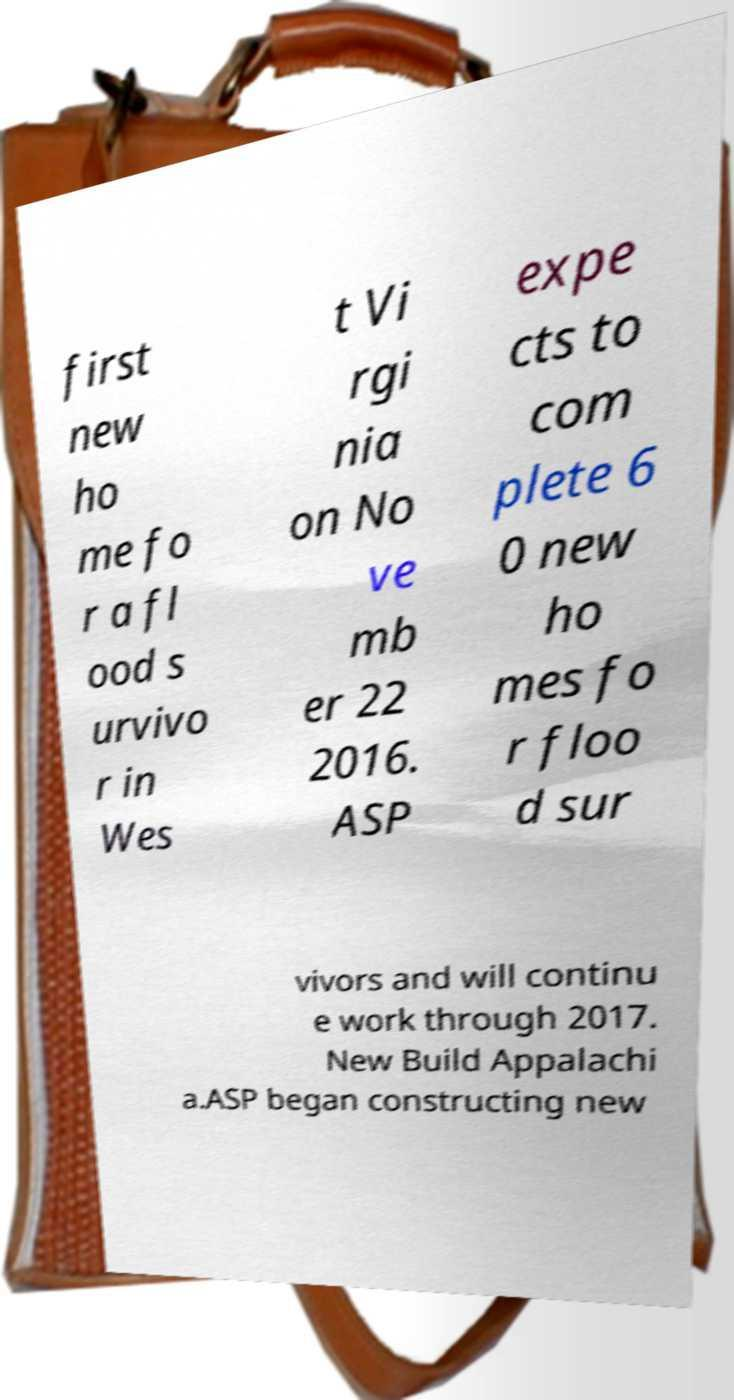There's text embedded in this image that I need extracted. Can you transcribe it verbatim? first new ho me fo r a fl ood s urvivo r in Wes t Vi rgi nia on No ve mb er 22 2016. ASP expe cts to com plete 6 0 new ho mes fo r floo d sur vivors and will continu e work through 2017. New Build Appalachi a.ASP began constructing new 